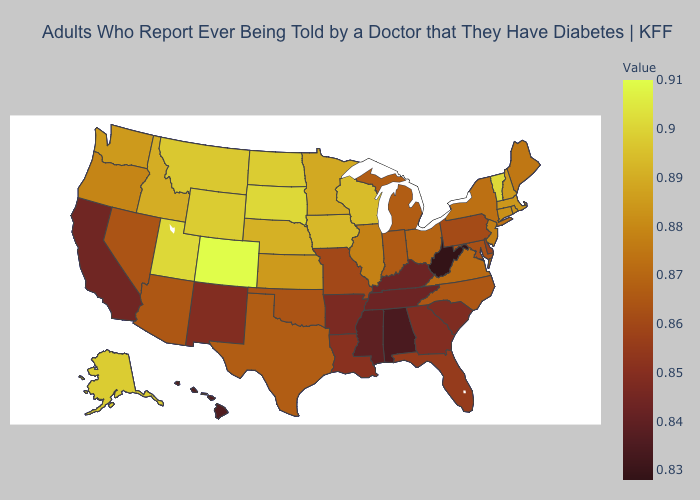Among the states that border New Hampshire , does Vermont have the lowest value?
Write a very short answer. No. Does Pennsylvania have the lowest value in the Northeast?
Answer briefly. Yes. Is the legend a continuous bar?
Write a very short answer. Yes. Does South Dakota have the highest value in the MidWest?
Answer briefly. Yes. Among the states that border North Dakota , which have the lowest value?
Write a very short answer. Minnesota. 